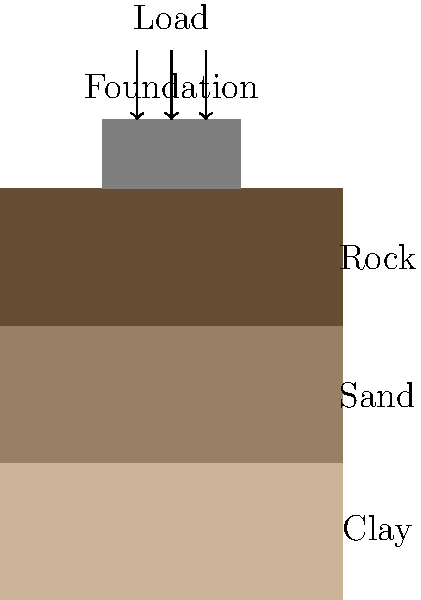A building foundation is constructed on a layered soil profile as shown in the figure. The foundation is 4m wide and applies a uniform pressure of 200 kPa. The soil profile consists of a 4m thick clay layer (E = 20 MPa), a 4m thick sand layer (E = 50 MPa), and bedrock. Using the 2:1 load distribution method and assuming the settlement of the bedrock is negligible, estimate the total settlement of the foundation in mm. To estimate the settlement of the foundation, we'll use the 2:1 load distribution method and calculate the settlement for each soil layer:

1. Calculate the stress increase at the midpoint of each layer:
   - Clay layer (z = 2m): 
     $$\Delta \sigma_1 = \frac{200 \cdot 4}{(4 + 2) \cdot (4 + 2)} = 66.67 \text{ kPa}$$
   - Sand layer (z = 6m): 
     $$\Delta \sigma_2 = \frac{200 \cdot 4}{(4 + 6) \cdot (4 + 6)} = 20 \text{ kPa}$$

2. Calculate the settlement for each layer:
   - Clay layer: 
     $$S_1 = \frac{\Delta \sigma_1 \cdot H_1}{E_1} = \frac{66.67 \cdot 4000}{20 \cdot 10^6} = 13.33 \text{ mm}$$
   - Sand layer: 
     $$S_2 = \frac{\Delta \sigma_2 \cdot H_2}{E_2} = \frac{20 \cdot 4000}{50 \cdot 10^6} = 1.60 \text{ mm}$$

3. Calculate the total settlement:
   $$S_{\text{total}} = S_1 + S_2 = 13.33 + 1.60 = 14.93 \text{ mm}$$

Therefore, the estimated total settlement of the foundation is approximately 14.93 mm.
Answer: 14.93 mm 